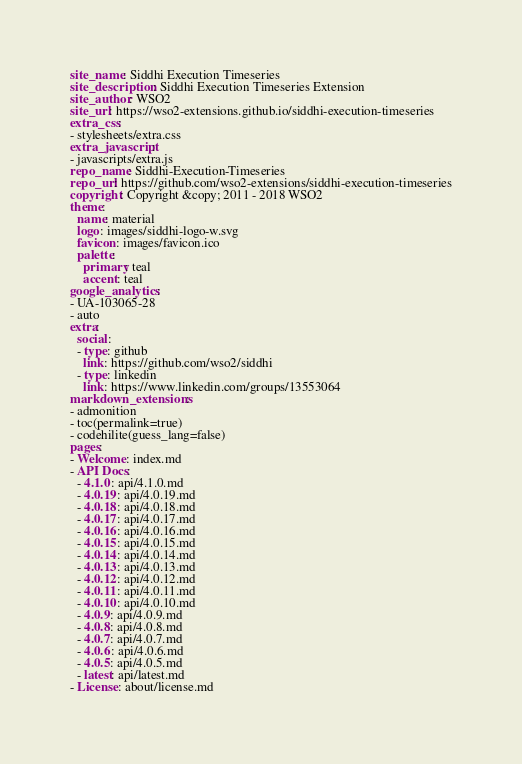<code> <loc_0><loc_0><loc_500><loc_500><_YAML_>site_name: Siddhi Execution Timeseries
site_description: Siddhi Execution Timeseries Extension
site_author: WSO2
site_url: https://wso2-extensions.github.io/siddhi-execution-timeseries
extra_css:
- stylesheets/extra.css
extra_javascript:
- javascripts/extra.js
repo_name: Siddhi-Execution-Timeseries
repo_url: https://github.com/wso2-extensions/siddhi-execution-timeseries
copyright: Copyright &copy; 2011 - 2018 WSO2
theme:
  name: material
  logo: images/siddhi-logo-w.svg
  favicon: images/favicon.ico
  palette:
    primary: teal
    accent: teal
google_analytics:
- UA-103065-28
- auto
extra:
  social:
  - type: github
    link: https://github.com/wso2/siddhi
  - type: linkedin
    link: https://www.linkedin.com/groups/13553064
markdown_extensions:
- admonition
- toc(permalink=true)
- codehilite(guess_lang=false)
pages:
- Welcome: index.md
- API Docs:
  - 4.1.0: api/4.1.0.md
  - 4.0.19: api/4.0.19.md
  - 4.0.18: api/4.0.18.md
  - 4.0.17: api/4.0.17.md
  - 4.0.16: api/4.0.16.md
  - 4.0.15: api/4.0.15.md
  - 4.0.14: api/4.0.14.md
  - 4.0.13: api/4.0.13.md
  - 4.0.12: api/4.0.12.md
  - 4.0.11: api/4.0.11.md
  - 4.0.10: api/4.0.10.md
  - 4.0.9: api/4.0.9.md
  - 4.0.8: api/4.0.8.md
  - 4.0.7: api/4.0.7.md
  - 4.0.6: api/4.0.6.md
  - 4.0.5: api/4.0.5.md
  - latest: api/latest.md
- License: about/license.md
</code> 